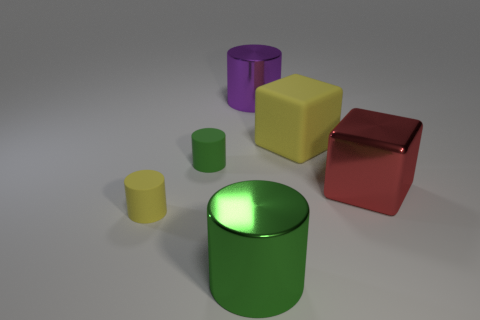How does the lighting in the image affect the appearance of the objects? The lighting creates a soft shadow on the right side of the objects, suggesting a light source to the top left, and highlights their three-dimensional form. 